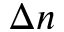Convert formula to latex. <formula><loc_0><loc_0><loc_500><loc_500>\Delta n</formula> 